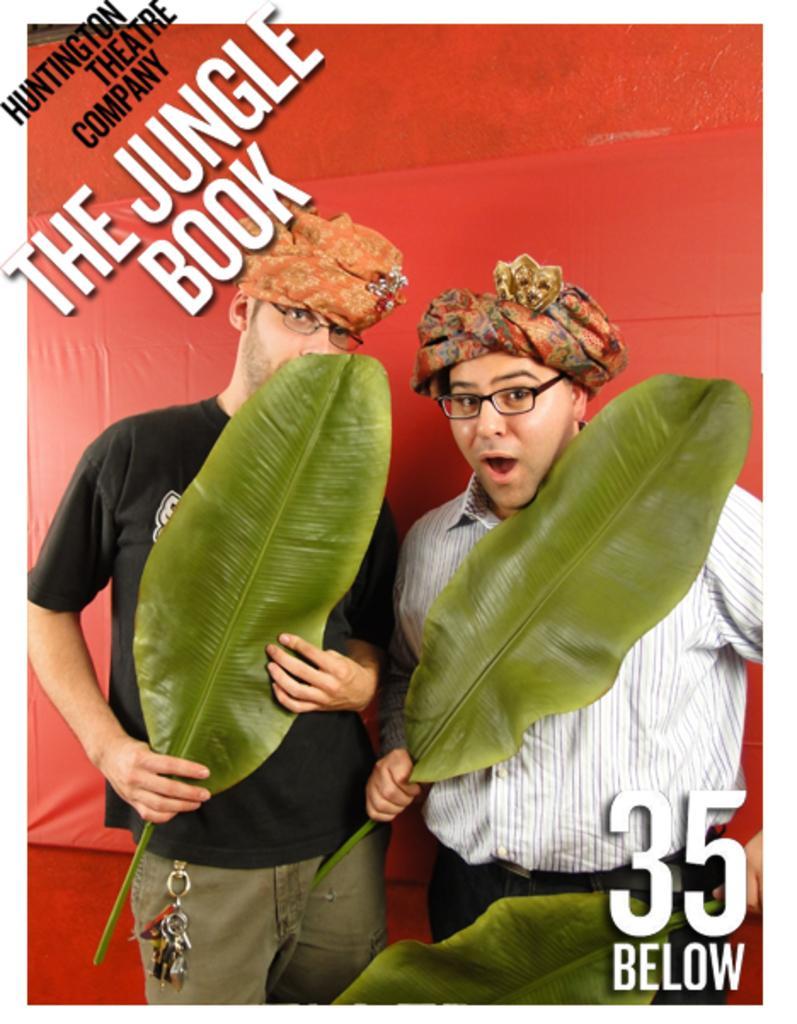Describe this image in one or two sentences. In this image we can see teo persons wearing black color T-shirt and white color shirt respectively holding banana leaves in their hands and standing also wearing spectacles and caps and in the background of the image there is red color sheet and some text. 